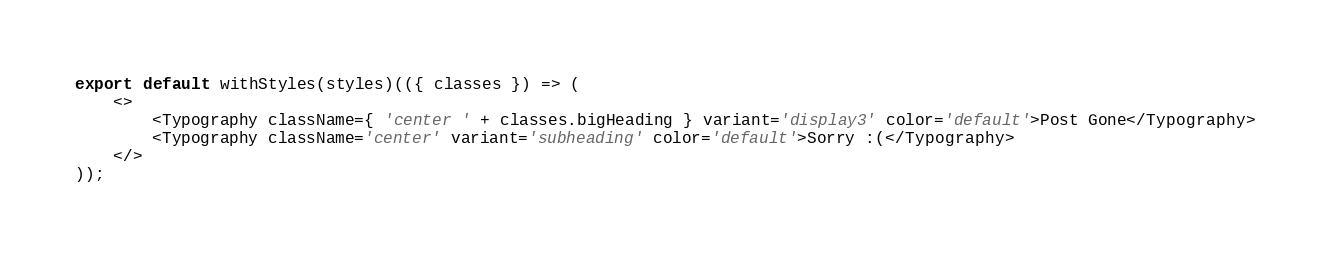<code> <loc_0><loc_0><loc_500><loc_500><_JavaScript_>
export default withStyles(styles)(({ classes }) => (
    <>
        <Typography className={ 'center ' + classes.bigHeading } variant='display3' color='default'>Post Gone</Typography>
        <Typography className='center' variant='subheading' color='default'>Sorry :(</Typography>
    </>
));</code> 